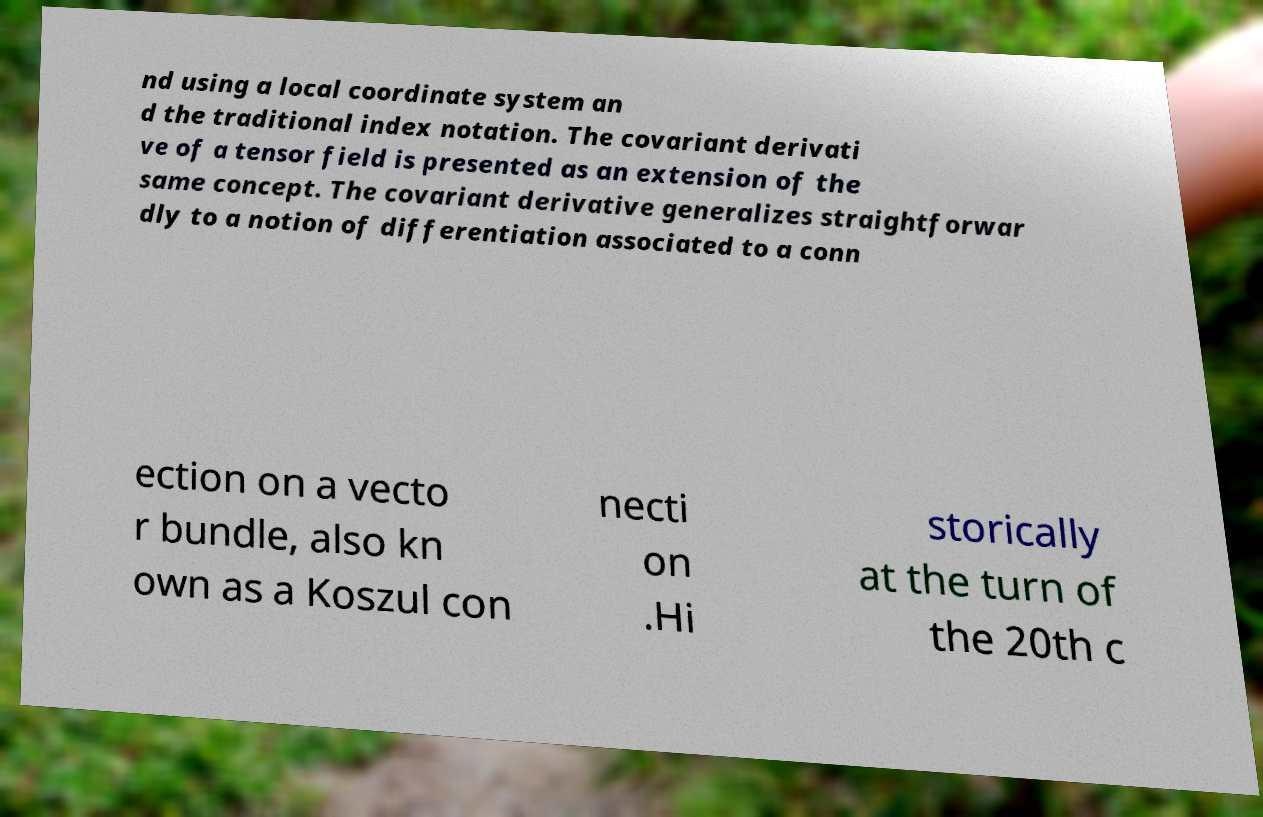Can you accurately transcribe the text from the provided image for me? nd using a local coordinate system an d the traditional index notation. The covariant derivati ve of a tensor field is presented as an extension of the same concept. The covariant derivative generalizes straightforwar dly to a notion of differentiation associated to a conn ection on a vecto r bundle, also kn own as a Koszul con necti on .Hi storically at the turn of the 20th c 